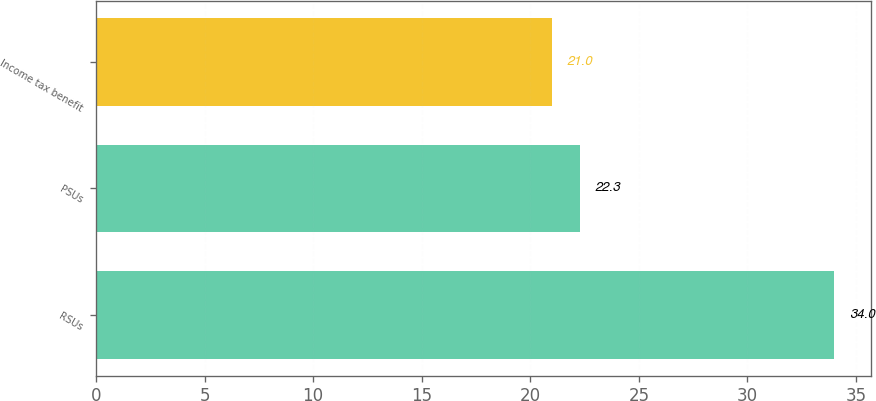Convert chart to OTSL. <chart><loc_0><loc_0><loc_500><loc_500><bar_chart><fcel>RSUs<fcel>PSUs<fcel>Income tax benefit<nl><fcel>34<fcel>22.3<fcel>21<nl></chart> 